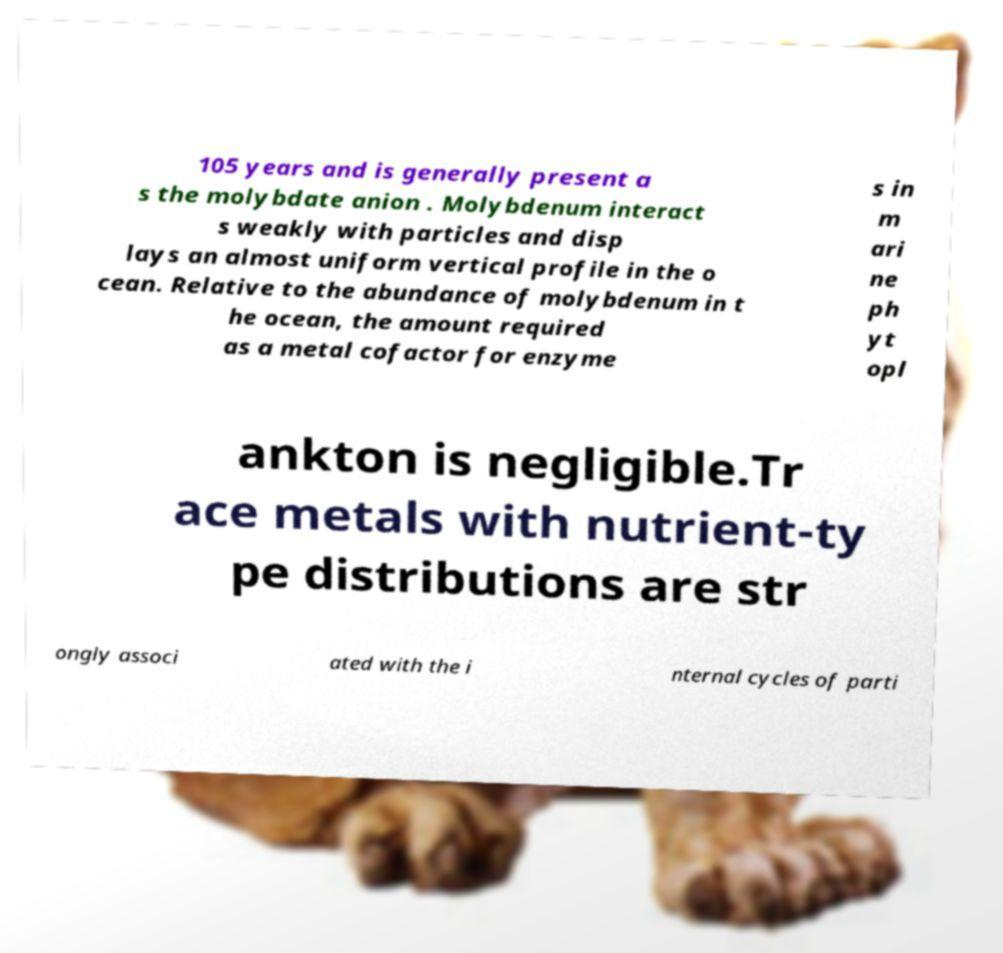I need the written content from this picture converted into text. Can you do that? 105 years and is generally present a s the molybdate anion . Molybdenum interact s weakly with particles and disp lays an almost uniform vertical profile in the o cean. Relative to the abundance of molybdenum in t he ocean, the amount required as a metal cofactor for enzyme s in m ari ne ph yt opl ankton is negligible.Tr ace metals with nutrient-ty pe distributions are str ongly associ ated with the i nternal cycles of parti 